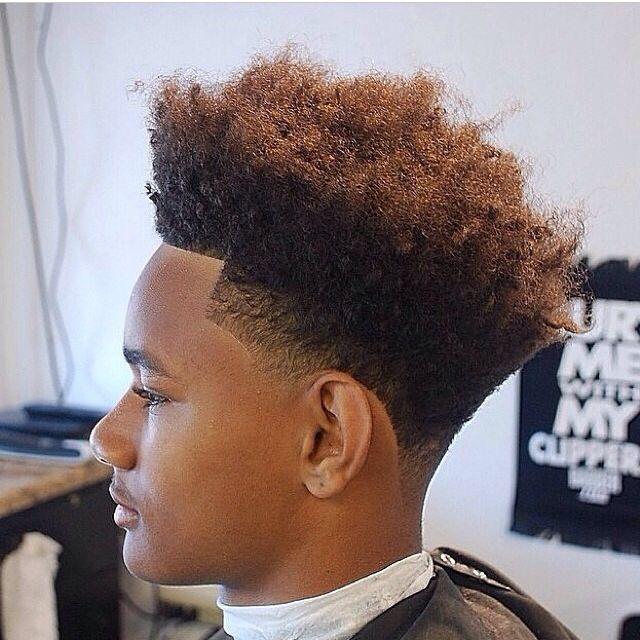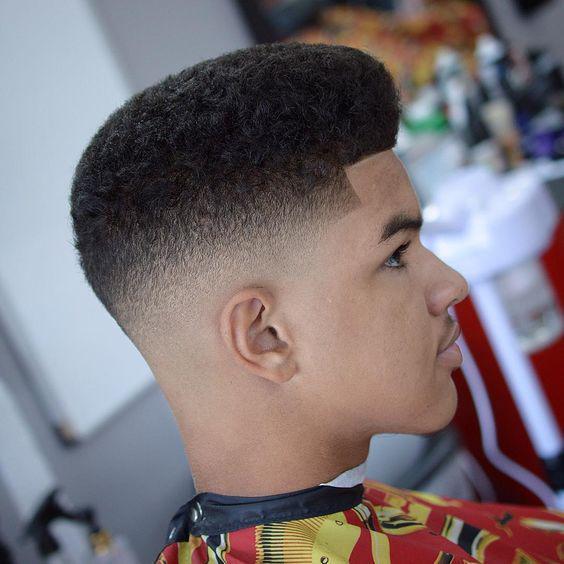The first image is the image on the left, the second image is the image on the right. For the images displayed, is the sentence "The left and right image contains the same number of men with fades." factually correct? Answer yes or no. Yes. The first image is the image on the left, the second image is the image on the right. Given the left and right images, does the statement "The left image shows a leftward-facing male with no beard on his chin and a haircut that creates an unbroken right angle on the side." hold true? Answer yes or no. Yes. 